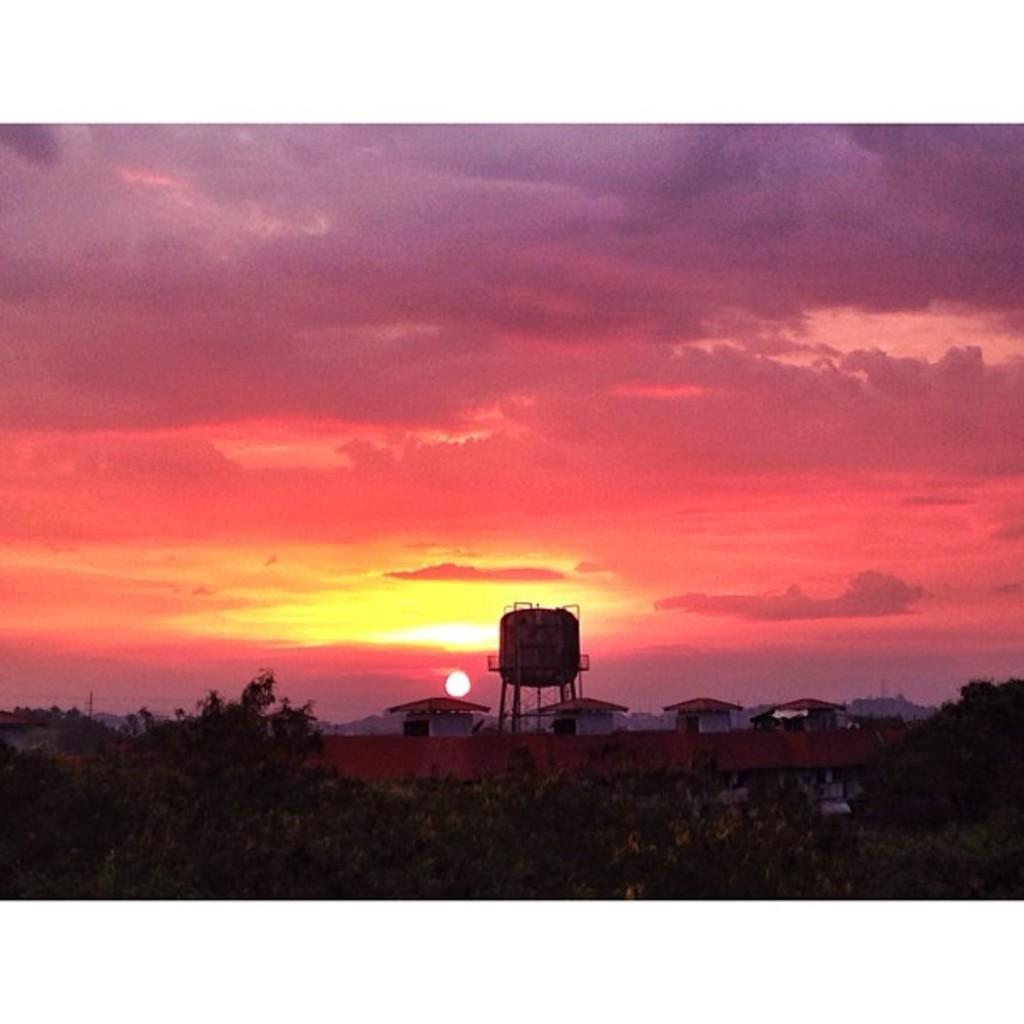What type of natural elements can be seen in the image? There are trees in the image. What type of man-made structures are present in the image? There are buildings in the image. Where are the trees and buildings located in the image? The trees and buildings are at the back of the image. What is visible in the sky in the image? The sun is visible in the sky. Where is the shelf located in the image? There is no shelf present in the image. What type of soap is being used by the trees in the image? There are no trees using soap in the image, as trees do not use soap. 